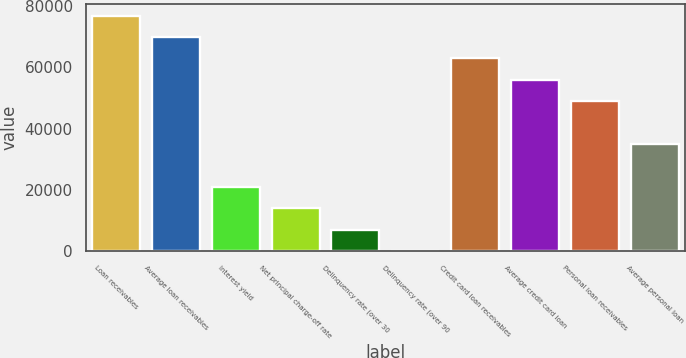Convert chart. <chart><loc_0><loc_0><loc_500><loc_500><bar_chart><fcel>Loan receivables<fcel>Average loan receivables<fcel>Interest yield<fcel>Net principal charge-off rate<fcel>Delinquency rate (over 30<fcel>Delinquency rate (over 90<fcel>Credit card loan receivables<fcel>Average credit card loan<fcel>Personal loan receivables<fcel>Average personal loan<nl><fcel>76965.8<fcel>69969<fcel>20991.2<fcel>13994.4<fcel>6997.6<fcel>0.78<fcel>62972.2<fcel>55975.3<fcel>48978.5<fcel>34984.9<nl></chart> 